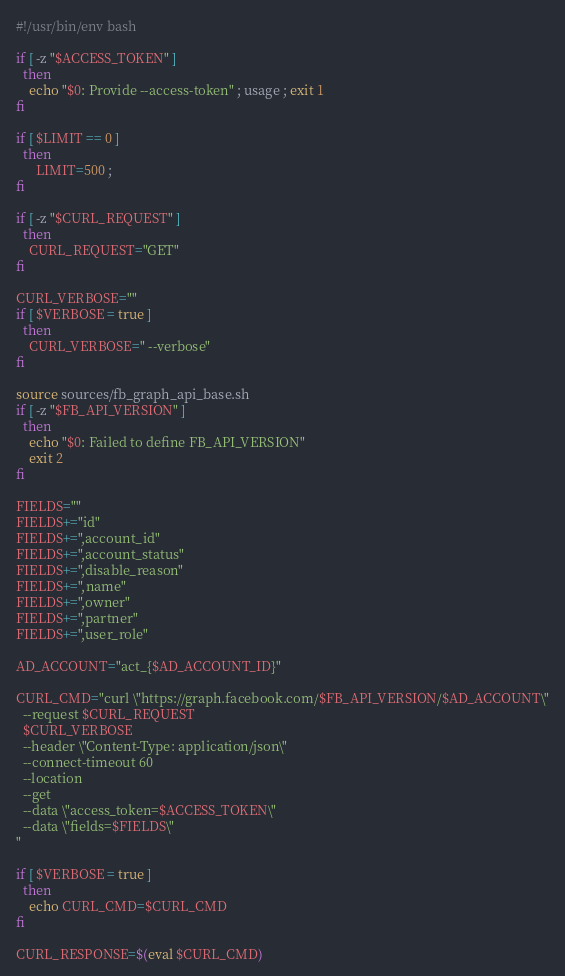Convert code to text. <code><loc_0><loc_0><loc_500><loc_500><_Bash_>#!/usr/bin/env bash

if [ -z "$ACCESS_TOKEN" ]
  then
    echo "$0: Provide --access-token" ; usage ; exit 1
fi

if [ $LIMIT == 0 ]
  then
      LIMIT=500 ;
fi

if [ -z "$CURL_REQUEST" ]
  then
    CURL_REQUEST="GET"
fi

CURL_VERBOSE=""
if [ $VERBOSE = true ]
  then
    CURL_VERBOSE=" --verbose"
fi

source sources/fb_graph_api_base.sh
if [ -z "$FB_API_VERSION" ]
  then
    echo "$0: Failed to define FB_API_VERSION"
    exit 2
fi

FIELDS=""
FIELDS+="id"
FIELDS+=",account_id"
FIELDS+=",account_status"
FIELDS+=",disable_reason"
FIELDS+=",name"
FIELDS+=",owner"
FIELDS+=",partner"
FIELDS+=",user_role"

AD_ACCOUNT="act_{$AD_ACCOUNT_ID}"

CURL_CMD="curl \"https://graph.facebook.com/$FB_API_VERSION/$AD_ACCOUNT\"
  --request $CURL_REQUEST
  $CURL_VERBOSE
  --header \"Content-Type: application/json\"
  --connect-timeout 60
  --location
  --get
  --data \"access_token=$ACCESS_TOKEN\"
  --data \"fields=$FIELDS\"
"

if [ $VERBOSE = true ]
  then
    echo CURL_CMD=$CURL_CMD
fi

CURL_RESPONSE=$(eval $CURL_CMD)</code> 